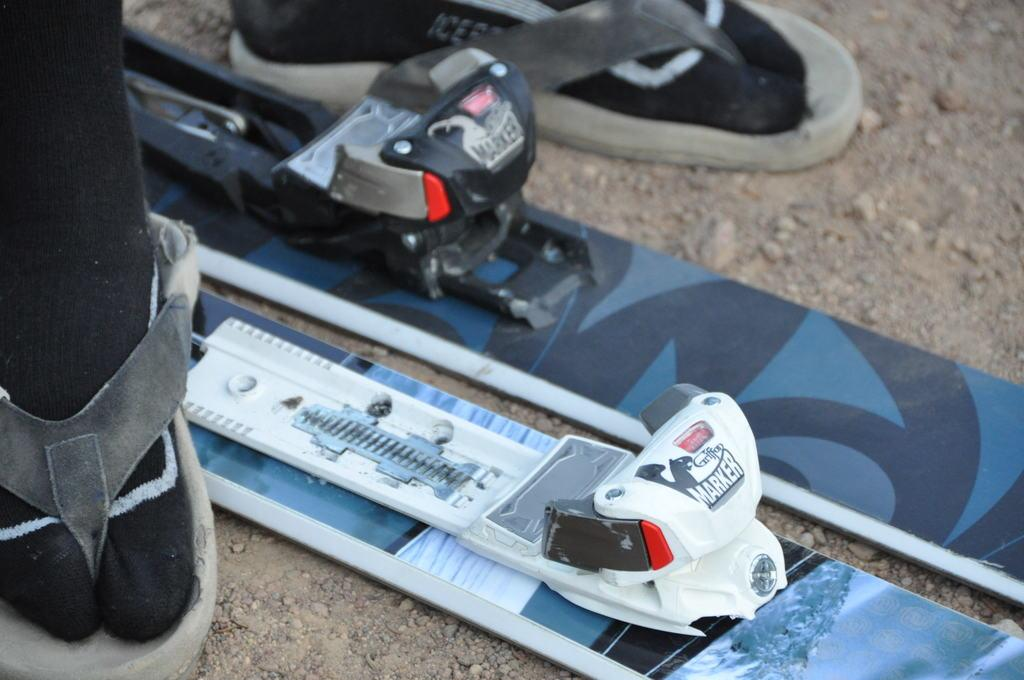What body parts are visible in the image? There are persons' legs visible in the image. What type of footwear are the legs wearing? The legs are wearing slippers. What equipment is associated with the activity in the image? There are skiing boards in the image. What is visible at the bottom of the image? The ground is visible at the bottom of the image. What type of yam is being used to create harmony in the image? There is no yam or reference to harmony in the image; it features persons' legs wearing slippers and skiing boards. 